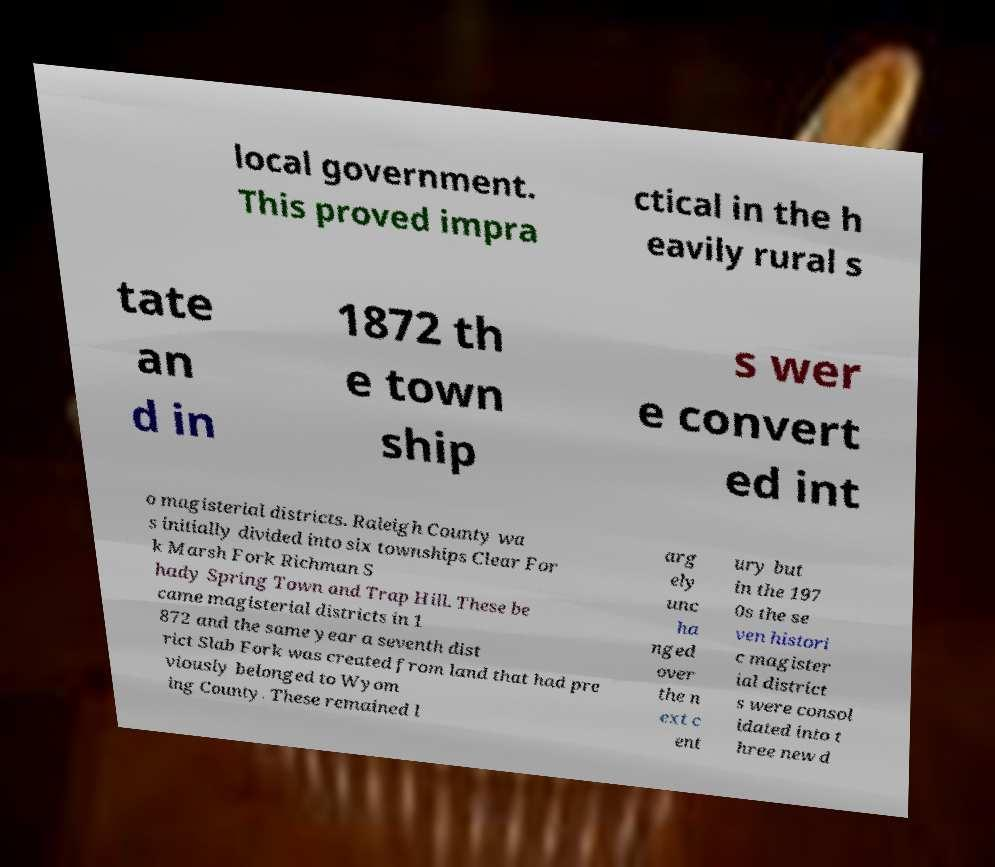Please read and relay the text visible in this image. What does it say? local government. This proved impra ctical in the h eavily rural s tate an d in 1872 th e town ship s wer e convert ed int o magisterial districts. Raleigh County wa s initially divided into six townships Clear For k Marsh Fork Richman S hady Spring Town and Trap Hill. These be came magisterial districts in 1 872 and the same year a seventh dist rict Slab Fork was created from land that had pre viously belonged to Wyom ing County. These remained l arg ely unc ha nged over the n ext c ent ury but in the 197 0s the se ven histori c magister ial district s were consol idated into t hree new d 